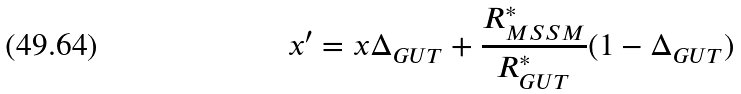Convert formula to latex. <formula><loc_0><loc_0><loc_500><loc_500>x ^ { \prime } = x \Delta _ { G U T } + \frac { R _ { M S S M } ^ { * } } { R _ { G U T } ^ { * } } ( 1 - \Delta _ { G U T } )</formula> 